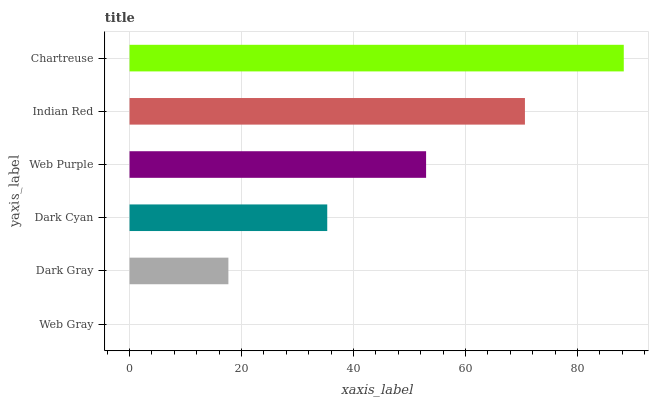Is Web Gray the minimum?
Answer yes or no. Yes. Is Chartreuse the maximum?
Answer yes or no. Yes. Is Dark Gray the minimum?
Answer yes or no. No. Is Dark Gray the maximum?
Answer yes or no. No. Is Dark Gray greater than Web Gray?
Answer yes or no. Yes. Is Web Gray less than Dark Gray?
Answer yes or no. Yes. Is Web Gray greater than Dark Gray?
Answer yes or no. No. Is Dark Gray less than Web Gray?
Answer yes or no. No. Is Web Purple the high median?
Answer yes or no. Yes. Is Dark Cyan the low median?
Answer yes or no. Yes. Is Dark Gray the high median?
Answer yes or no. No. Is Dark Gray the low median?
Answer yes or no. No. 